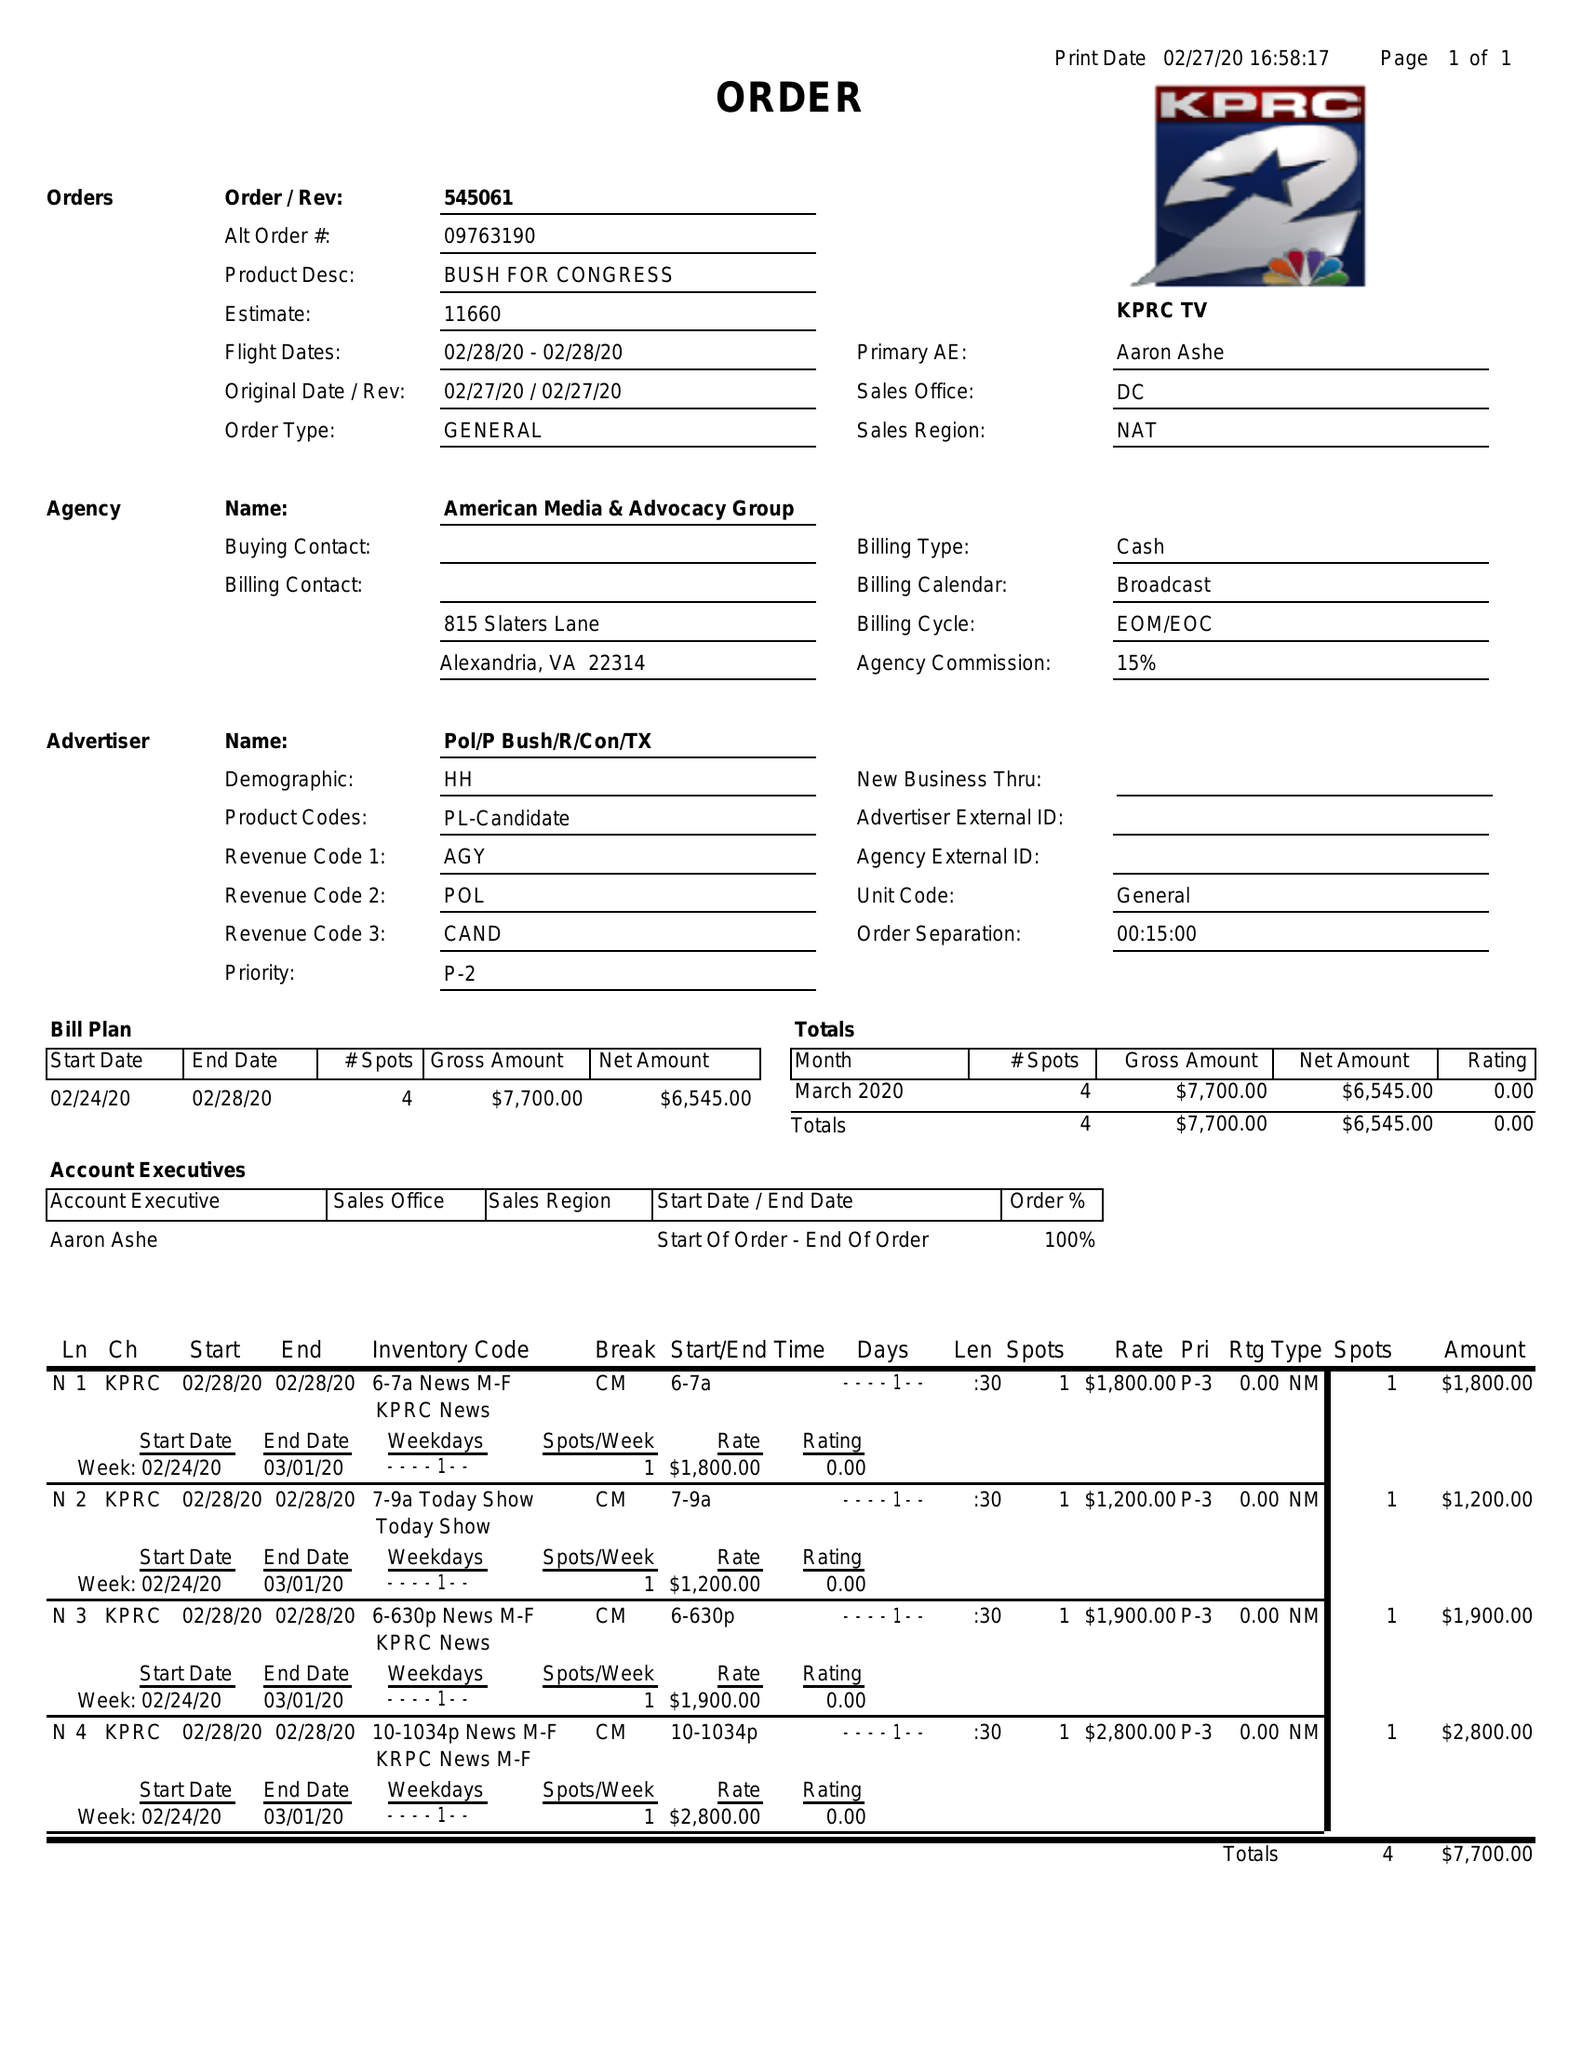What is the value for the flight_to?
Answer the question using a single word or phrase. 02/28/20 